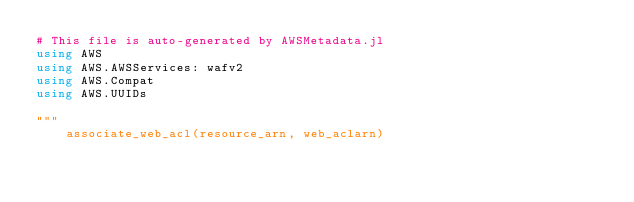<code> <loc_0><loc_0><loc_500><loc_500><_Julia_># This file is auto-generated by AWSMetadata.jl
using AWS
using AWS.AWSServices: wafv2
using AWS.Compat
using AWS.UUIDs

"""
    associate_web_acl(resource_arn, web_aclarn)</code> 